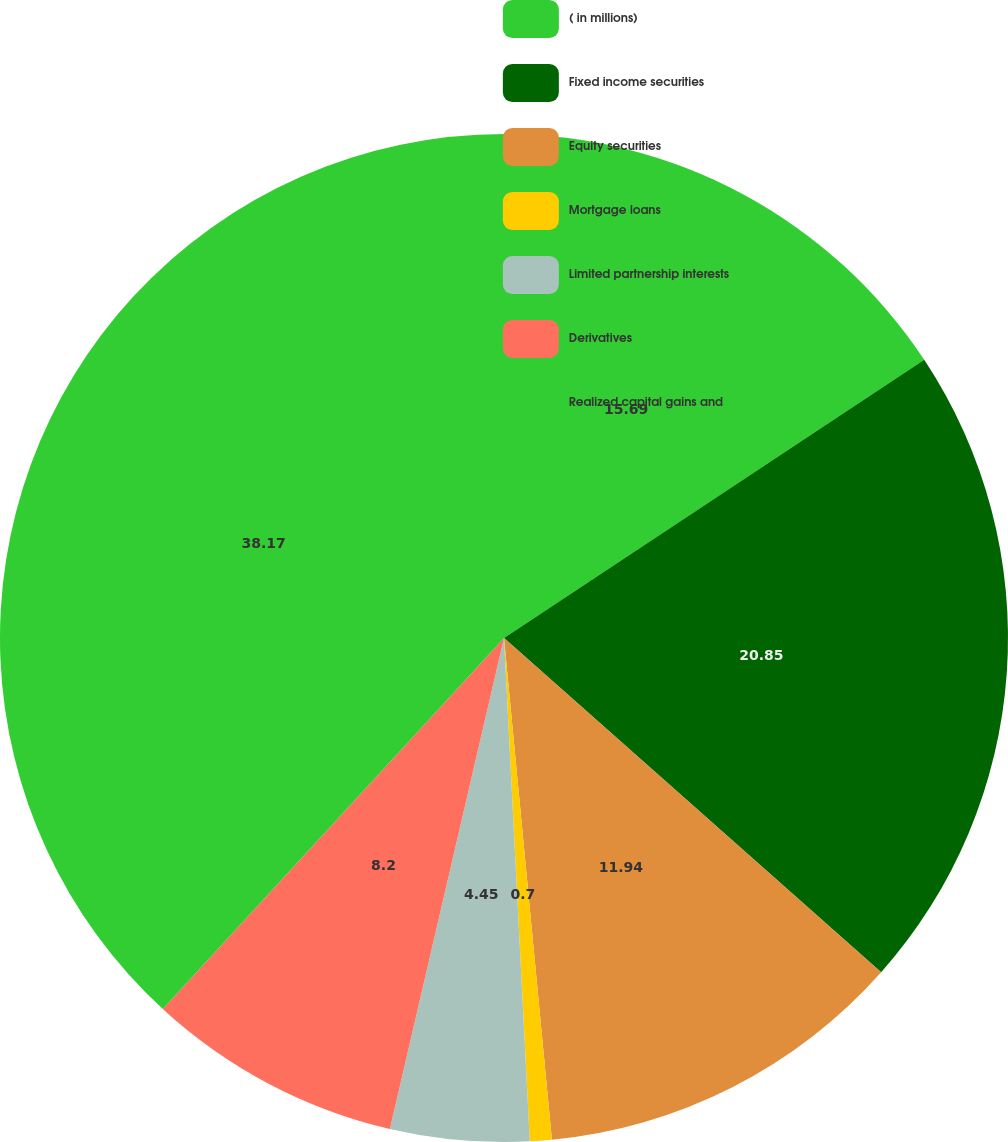Convert chart. <chart><loc_0><loc_0><loc_500><loc_500><pie_chart><fcel>( in millions)<fcel>Fixed income securities<fcel>Equity securities<fcel>Mortgage loans<fcel>Limited partnership interests<fcel>Derivatives<fcel>Realized capital gains and<nl><fcel>15.69%<fcel>20.85%<fcel>11.94%<fcel>0.7%<fcel>4.45%<fcel>8.2%<fcel>38.16%<nl></chart> 